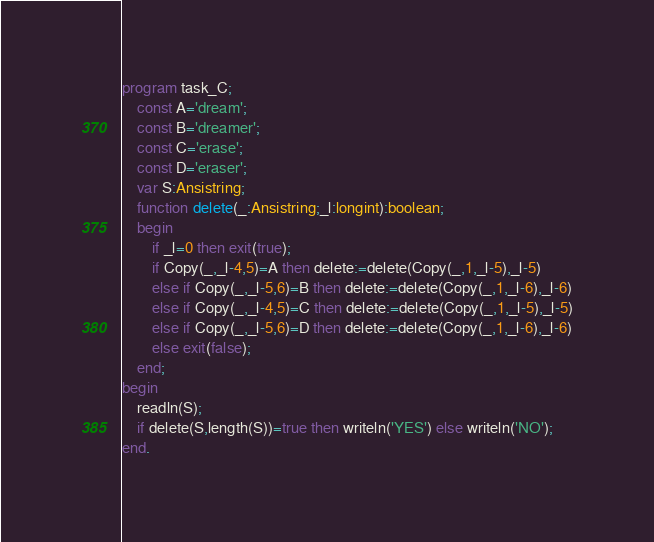Convert code to text. <code><loc_0><loc_0><loc_500><loc_500><_Pascal_>program task_C;
    const A='dream';
    const B='dreamer';
    const C='erase';
    const D='eraser';
    var S:Ansistring;
    function delete(_:Ansistring;_l:longint):boolean;
    begin
        if _l=0 then exit(true);
        if Copy(_,_l-4,5)=A then delete:=delete(Copy(_,1,_l-5),_l-5)
        else if Copy(_,_l-5,6)=B then delete:=delete(Copy(_,1,_l-6),_l-6)
        else if Copy(_,_l-4,5)=C then delete:=delete(Copy(_,1,_l-5),_l-5)
        else if Copy(_,_l-5,6)=D then delete:=delete(Copy(_,1,_l-6),_l-6)
        else exit(false);
    end;
begin
    readln(S);
    if delete(S,length(S))=true then writeln('YES') else writeln('NO');
end.</code> 